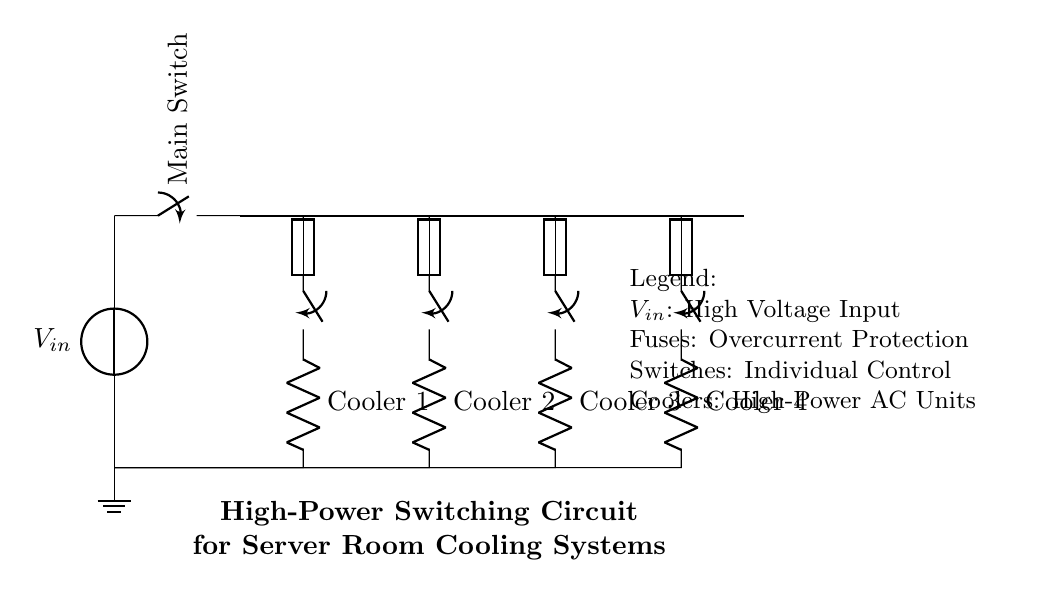What is the main function of the switch connected to the voltage source? The switch controls the connection between the voltage source and the distribution bus, allowing or interrupting the flow of electricity.
Answer: Control What component provides overcurrent protection in the circuit? The circuit includes fuses in series with the cooling systems, which protect against excess current by breaking the circuit when the current exceeds a specified limit.
Answer: Fuses How many cooling systems are present in the circuit? The circuit includes four distinct cooling systems, each with its own switch and fuse, as indicated by the four labeled resistive components.
Answer: Four What is the voltage input designation in the diagram? The voltage input is labeled as "V in", representing the incoming high voltage supply for the circuit.
Answer: V in What is the significance of the ground connection in this circuit? The ground connection serves as a reference point for the circuit's voltage levels and provides safety by directing any fault current away from equipment or personnel.
Answer: Safety Which cooling system is represented by the second component from the left? The second cooling system is labeled as "Cooler 2", corresponding to the second resistor marked in the series connected to its own fuse and switch.
Answer: Cooler 2 What would happen if one of the fuses blew in the circuit? If a fuse blew, it would interrupt the current flow to the corresponding cooling system, causing that unit to shut down while allowing the other systems to continue operating.
Answer: Shut down 